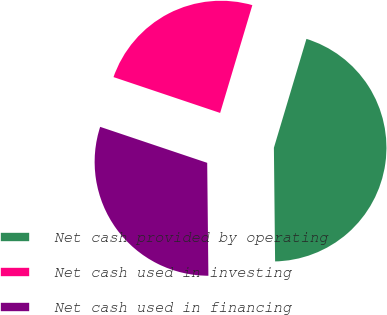Convert chart to OTSL. <chart><loc_0><loc_0><loc_500><loc_500><pie_chart><fcel>Net cash provided by operating<fcel>Net cash used in investing<fcel>Net cash used in financing<nl><fcel>45.21%<fcel>24.46%<fcel>30.33%<nl></chart> 